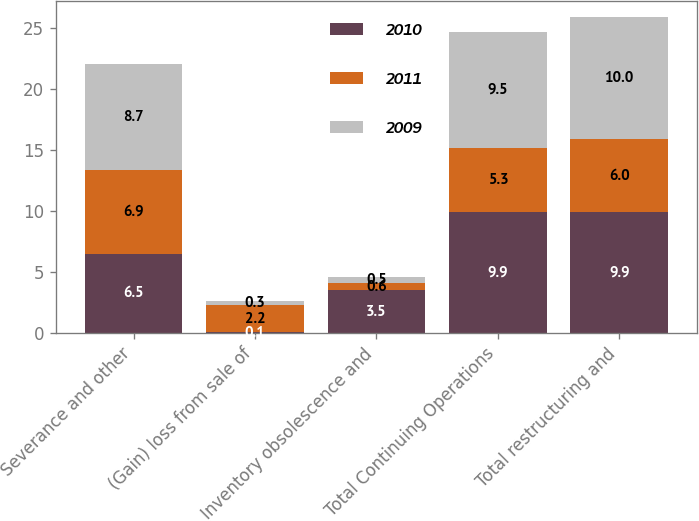<chart> <loc_0><loc_0><loc_500><loc_500><stacked_bar_chart><ecel><fcel>Severance and other<fcel>(Gain) loss from sale of<fcel>Inventory obsolescence and<fcel>Total Continuing Operations<fcel>Total restructuring and<nl><fcel>2010<fcel>6.5<fcel>0.1<fcel>3.5<fcel>9.9<fcel>9.9<nl><fcel>2011<fcel>6.9<fcel>2.2<fcel>0.6<fcel>5.3<fcel>6<nl><fcel>2009<fcel>8.7<fcel>0.3<fcel>0.5<fcel>9.5<fcel>10<nl></chart> 